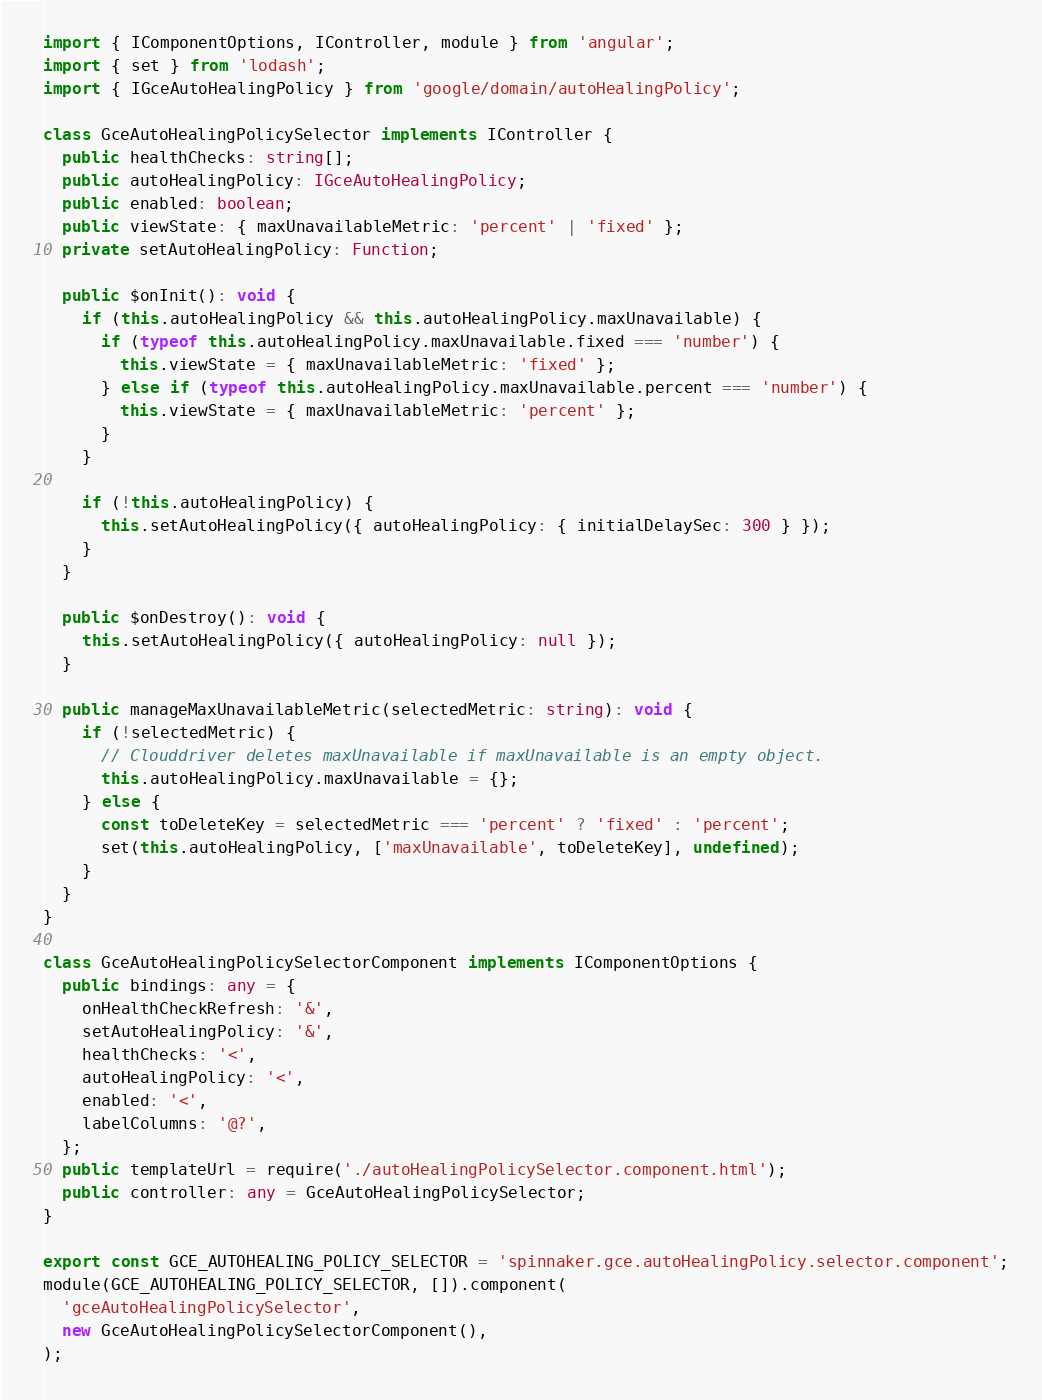<code> <loc_0><loc_0><loc_500><loc_500><_TypeScript_>import { IComponentOptions, IController, module } from 'angular';
import { set } from 'lodash';
import { IGceAutoHealingPolicy } from 'google/domain/autoHealingPolicy';

class GceAutoHealingPolicySelector implements IController {
  public healthChecks: string[];
  public autoHealingPolicy: IGceAutoHealingPolicy;
  public enabled: boolean;
  public viewState: { maxUnavailableMetric: 'percent' | 'fixed' };
  private setAutoHealingPolicy: Function;

  public $onInit(): void {
    if (this.autoHealingPolicy && this.autoHealingPolicy.maxUnavailable) {
      if (typeof this.autoHealingPolicy.maxUnavailable.fixed === 'number') {
        this.viewState = { maxUnavailableMetric: 'fixed' };
      } else if (typeof this.autoHealingPolicy.maxUnavailable.percent === 'number') {
        this.viewState = { maxUnavailableMetric: 'percent' };
      }
    }

    if (!this.autoHealingPolicy) {
      this.setAutoHealingPolicy({ autoHealingPolicy: { initialDelaySec: 300 } });
    }
  }

  public $onDestroy(): void {
    this.setAutoHealingPolicy({ autoHealingPolicy: null });
  }

  public manageMaxUnavailableMetric(selectedMetric: string): void {
    if (!selectedMetric) {
      // Clouddriver deletes maxUnavailable if maxUnavailable is an empty object.
      this.autoHealingPolicy.maxUnavailable = {};
    } else {
      const toDeleteKey = selectedMetric === 'percent' ? 'fixed' : 'percent';
      set(this.autoHealingPolicy, ['maxUnavailable', toDeleteKey], undefined);
    }
  }
}

class GceAutoHealingPolicySelectorComponent implements IComponentOptions {
  public bindings: any = {
    onHealthCheckRefresh: '&',
    setAutoHealingPolicy: '&',
    healthChecks: '<',
    autoHealingPolicy: '<',
    enabled: '<',
    labelColumns: '@?',
  };
  public templateUrl = require('./autoHealingPolicySelector.component.html');
  public controller: any = GceAutoHealingPolicySelector;
}

export const GCE_AUTOHEALING_POLICY_SELECTOR = 'spinnaker.gce.autoHealingPolicy.selector.component';
module(GCE_AUTOHEALING_POLICY_SELECTOR, []).component(
  'gceAutoHealingPolicySelector',
  new GceAutoHealingPolicySelectorComponent(),
);
</code> 